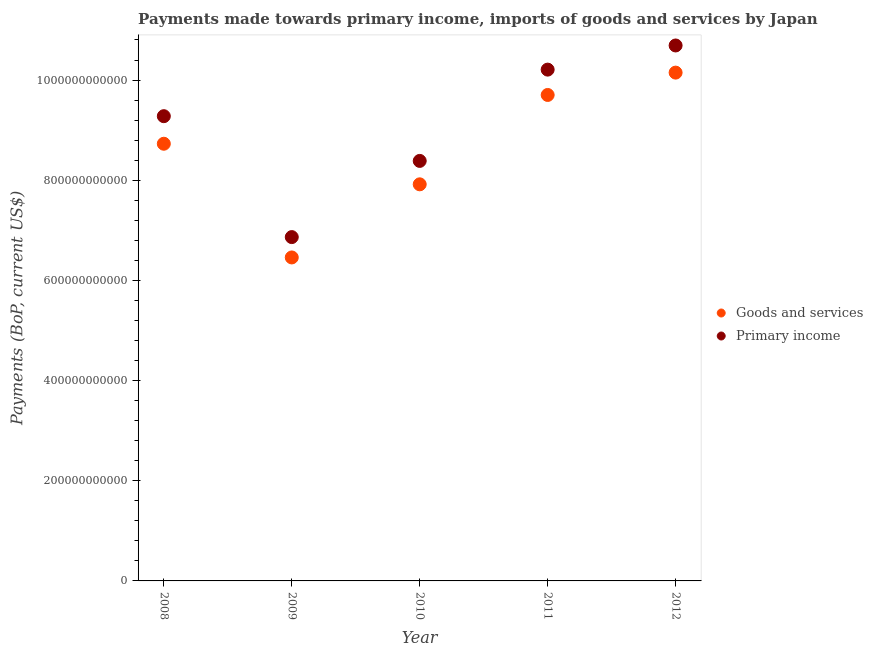Is the number of dotlines equal to the number of legend labels?
Your response must be concise. Yes. What is the payments made towards goods and services in 2008?
Make the answer very short. 8.73e+11. Across all years, what is the maximum payments made towards goods and services?
Your answer should be compact. 1.01e+12. Across all years, what is the minimum payments made towards primary income?
Your answer should be very brief. 6.86e+11. In which year was the payments made towards primary income maximum?
Your response must be concise. 2012. What is the total payments made towards goods and services in the graph?
Make the answer very short. 4.30e+12. What is the difference between the payments made towards goods and services in 2008 and that in 2009?
Make the answer very short. 2.27e+11. What is the difference between the payments made towards goods and services in 2011 and the payments made towards primary income in 2012?
Keep it short and to the point. -9.88e+1. What is the average payments made towards goods and services per year?
Your answer should be compact. 8.59e+11. In the year 2009, what is the difference between the payments made towards primary income and payments made towards goods and services?
Your answer should be compact. 4.06e+1. In how many years, is the payments made towards goods and services greater than 40000000000 US$?
Offer a terse response. 5. What is the ratio of the payments made towards goods and services in 2009 to that in 2011?
Your response must be concise. 0.67. Is the payments made towards goods and services in 2008 less than that in 2010?
Make the answer very short. No. Is the difference between the payments made towards goods and services in 2009 and 2012 greater than the difference between the payments made towards primary income in 2009 and 2012?
Your response must be concise. Yes. What is the difference between the highest and the second highest payments made towards primary income?
Make the answer very short. 4.82e+1. What is the difference between the highest and the lowest payments made towards primary income?
Your answer should be very brief. 3.83e+11. Is the sum of the payments made towards goods and services in 2010 and 2012 greater than the maximum payments made towards primary income across all years?
Give a very brief answer. Yes. Is the payments made towards primary income strictly greater than the payments made towards goods and services over the years?
Offer a terse response. Yes. How many dotlines are there?
Your response must be concise. 2. What is the difference between two consecutive major ticks on the Y-axis?
Your answer should be very brief. 2.00e+11. Are the values on the major ticks of Y-axis written in scientific E-notation?
Provide a short and direct response. No. Does the graph contain grids?
Ensure brevity in your answer.  No. Where does the legend appear in the graph?
Offer a terse response. Center right. What is the title of the graph?
Keep it short and to the point. Payments made towards primary income, imports of goods and services by Japan. What is the label or title of the X-axis?
Your answer should be very brief. Year. What is the label or title of the Y-axis?
Your response must be concise. Payments (BoP, current US$). What is the Payments (BoP, current US$) of Goods and services in 2008?
Offer a very short reply. 8.73e+11. What is the Payments (BoP, current US$) of Primary income in 2008?
Your response must be concise. 9.28e+11. What is the Payments (BoP, current US$) of Goods and services in 2009?
Your answer should be compact. 6.46e+11. What is the Payments (BoP, current US$) of Primary income in 2009?
Your response must be concise. 6.86e+11. What is the Payments (BoP, current US$) of Goods and services in 2010?
Your response must be concise. 7.92e+11. What is the Payments (BoP, current US$) in Primary income in 2010?
Your answer should be compact. 8.39e+11. What is the Payments (BoP, current US$) in Goods and services in 2011?
Offer a very short reply. 9.70e+11. What is the Payments (BoP, current US$) of Primary income in 2011?
Keep it short and to the point. 1.02e+12. What is the Payments (BoP, current US$) in Goods and services in 2012?
Your response must be concise. 1.01e+12. What is the Payments (BoP, current US$) of Primary income in 2012?
Provide a short and direct response. 1.07e+12. Across all years, what is the maximum Payments (BoP, current US$) in Goods and services?
Provide a succinct answer. 1.01e+12. Across all years, what is the maximum Payments (BoP, current US$) in Primary income?
Ensure brevity in your answer.  1.07e+12. Across all years, what is the minimum Payments (BoP, current US$) in Goods and services?
Provide a succinct answer. 6.46e+11. Across all years, what is the minimum Payments (BoP, current US$) in Primary income?
Offer a very short reply. 6.86e+11. What is the total Payments (BoP, current US$) of Goods and services in the graph?
Provide a succinct answer. 4.30e+12. What is the total Payments (BoP, current US$) of Primary income in the graph?
Keep it short and to the point. 4.54e+12. What is the difference between the Payments (BoP, current US$) in Goods and services in 2008 and that in 2009?
Keep it short and to the point. 2.27e+11. What is the difference between the Payments (BoP, current US$) in Primary income in 2008 and that in 2009?
Provide a succinct answer. 2.41e+11. What is the difference between the Payments (BoP, current US$) in Goods and services in 2008 and that in 2010?
Make the answer very short. 8.10e+1. What is the difference between the Payments (BoP, current US$) of Primary income in 2008 and that in 2010?
Provide a succinct answer. 8.93e+1. What is the difference between the Payments (BoP, current US$) in Goods and services in 2008 and that in 2011?
Keep it short and to the point. -9.74e+1. What is the difference between the Payments (BoP, current US$) of Primary income in 2008 and that in 2011?
Ensure brevity in your answer.  -9.29e+1. What is the difference between the Payments (BoP, current US$) of Goods and services in 2008 and that in 2012?
Offer a terse response. -1.42e+11. What is the difference between the Payments (BoP, current US$) in Primary income in 2008 and that in 2012?
Offer a terse response. -1.41e+11. What is the difference between the Payments (BoP, current US$) in Goods and services in 2009 and that in 2010?
Ensure brevity in your answer.  -1.46e+11. What is the difference between the Payments (BoP, current US$) of Primary income in 2009 and that in 2010?
Your answer should be compact. -1.52e+11. What is the difference between the Payments (BoP, current US$) of Goods and services in 2009 and that in 2011?
Your answer should be very brief. -3.24e+11. What is the difference between the Payments (BoP, current US$) of Primary income in 2009 and that in 2011?
Your response must be concise. -3.34e+11. What is the difference between the Payments (BoP, current US$) of Goods and services in 2009 and that in 2012?
Your answer should be compact. -3.69e+11. What is the difference between the Payments (BoP, current US$) in Primary income in 2009 and that in 2012?
Provide a succinct answer. -3.83e+11. What is the difference between the Payments (BoP, current US$) of Goods and services in 2010 and that in 2011?
Offer a very short reply. -1.78e+11. What is the difference between the Payments (BoP, current US$) in Primary income in 2010 and that in 2011?
Your response must be concise. -1.82e+11. What is the difference between the Payments (BoP, current US$) of Goods and services in 2010 and that in 2012?
Provide a short and direct response. -2.23e+11. What is the difference between the Payments (BoP, current US$) of Primary income in 2010 and that in 2012?
Your answer should be very brief. -2.30e+11. What is the difference between the Payments (BoP, current US$) of Goods and services in 2011 and that in 2012?
Ensure brevity in your answer.  -4.46e+1. What is the difference between the Payments (BoP, current US$) of Primary income in 2011 and that in 2012?
Your answer should be very brief. -4.82e+1. What is the difference between the Payments (BoP, current US$) in Goods and services in 2008 and the Payments (BoP, current US$) in Primary income in 2009?
Provide a succinct answer. 1.86e+11. What is the difference between the Payments (BoP, current US$) in Goods and services in 2008 and the Payments (BoP, current US$) in Primary income in 2010?
Make the answer very short. 3.43e+1. What is the difference between the Payments (BoP, current US$) of Goods and services in 2008 and the Payments (BoP, current US$) of Primary income in 2011?
Offer a terse response. -1.48e+11. What is the difference between the Payments (BoP, current US$) in Goods and services in 2008 and the Payments (BoP, current US$) in Primary income in 2012?
Your response must be concise. -1.96e+11. What is the difference between the Payments (BoP, current US$) in Goods and services in 2009 and the Payments (BoP, current US$) in Primary income in 2010?
Keep it short and to the point. -1.93e+11. What is the difference between the Payments (BoP, current US$) in Goods and services in 2009 and the Payments (BoP, current US$) in Primary income in 2011?
Make the answer very short. -3.75e+11. What is the difference between the Payments (BoP, current US$) of Goods and services in 2009 and the Payments (BoP, current US$) of Primary income in 2012?
Provide a succinct answer. -4.23e+11. What is the difference between the Payments (BoP, current US$) of Goods and services in 2010 and the Payments (BoP, current US$) of Primary income in 2011?
Offer a very short reply. -2.29e+11. What is the difference between the Payments (BoP, current US$) in Goods and services in 2010 and the Payments (BoP, current US$) in Primary income in 2012?
Offer a terse response. -2.77e+11. What is the difference between the Payments (BoP, current US$) of Goods and services in 2011 and the Payments (BoP, current US$) of Primary income in 2012?
Your answer should be very brief. -9.88e+1. What is the average Payments (BoP, current US$) of Goods and services per year?
Offer a very short reply. 8.59e+11. What is the average Payments (BoP, current US$) in Primary income per year?
Offer a terse response. 9.09e+11. In the year 2008, what is the difference between the Payments (BoP, current US$) of Goods and services and Payments (BoP, current US$) of Primary income?
Give a very brief answer. -5.50e+1. In the year 2009, what is the difference between the Payments (BoP, current US$) in Goods and services and Payments (BoP, current US$) in Primary income?
Give a very brief answer. -4.06e+1. In the year 2010, what is the difference between the Payments (BoP, current US$) of Goods and services and Payments (BoP, current US$) of Primary income?
Offer a terse response. -4.67e+1. In the year 2011, what is the difference between the Payments (BoP, current US$) in Goods and services and Payments (BoP, current US$) in Primary income?
Ensure brevity in your answer.  -5.06e+1. In the year 2012, what is the difference between the Payments (BoP, current US$) of Goods and services and Payments (BoP, current US$) of Primary income?
Offer a terse response. -5.42e+1. What is the ratio of the Payments (BoP, current US$) in Goods and services in 2008 to that in 2009?
Provide a succinct answer. 1.35. What is the ratio of the Payments (BoP, current US$) of Primary income in 2008 to that in 2009?
Your answer should be very brief. 1.35. What is the ratio of the Payments (BoP, current US$) of Goods and services in 2008 to that in 2010?
Ensure brevity in your answer.  1.1. What is the ratio of the Payments (BoP, current US$) in Primary income in 2008 to that in 2010?
Your answer should be compact. 1.11. What is the ratio of the Payments (BoP, current US$) of Goods and services in 2008 to that in 2011?
Keep it short and to the point. 0.9. What is the ratio of the Payments (BoP, current US$) of Primary income in 2008 to that in 2011?
Provide a succinct answer. 0.91. What is the ratio of the Payments (BoP, current US$) in Goods and services in 2008 to that in 2012?
Provide a short and direct response. 0.86. What is the ratio of the Payments (BoP, current US$) of Primary income in 2008 to that in 2012?
Give a very brief answer. 0.87. What is the ratio of the Payments (BoP, current US$) of Goods and services in 2009 to that in 2010?
Your answer should be very brief. 0.82. What is the ratio of the Payments (BoP, current US$) of Primary income in 2009 to that in 2010?
Your answer should be compact. 0.82. What is the ratio of the Payments (BoP, current US$) in Goods and services in 2009 to that in 2011?
Your response must be concise. 0.67. What is the ratio of the Payments (BoP, current US$) of Primary income in 2009 to that in 2011?
Provide a succinct answer. 0.67. What is the ratio of the Payments (BoP, current US$) of Goods and services in 2009 to that in 2012?
Give a very brief answer. 0.64. What is the ratio of the Payments (BoP, current US$) in Primary income in 2009 to that in 2012?
Keep it short and to the point. 0.64. What is the ratio of the Payments (BoP, current US$) in Goods and services in 2010 to that in 2011?
Give a very brief answer. 0.82. What is the ratio of the Payments (BoP, current US$) of Primary income in 2010 to that in 2011?
Keep it short and to the point. 0.82. What is the ratio of the Payments (BoP, current US$) of Goods and services in 2010 to that in 2012?
Offer a very short reply. 0.78. What is the ratio of the Payments (BoP, current US$) in Primary income in 2010 to that in 2012?
Give a very brief answer. 0.78. What is the ratio of the Payments (BoP, current US$) in Goods and services in 2011 to that in 2012?
Give a very brief answer. 0.96. What is the ratio of the Payments (BoP, current US$) in Primary income in 2011 to that in 2012?
Offer a terse response. 0.95. What is the difference between the highest and the second highest Payments (BoP, current US$) in Goods and services?
Give a very brief answer. 4.46e+1. What is the difference between the highest and the second highest Payments (BoP, current US$) in Primary income?
Offer a terse response. 4.82e+1. What is the difference between the highest and the lowest Payments (BoP, current US$) of Goods and services?
Provide a short and direct response. 3.69e+11. What is the difference between the highest and the lowest Payments (BoP, current US$) of Primary income?
Your answer should be compact. 3.83e+11. 